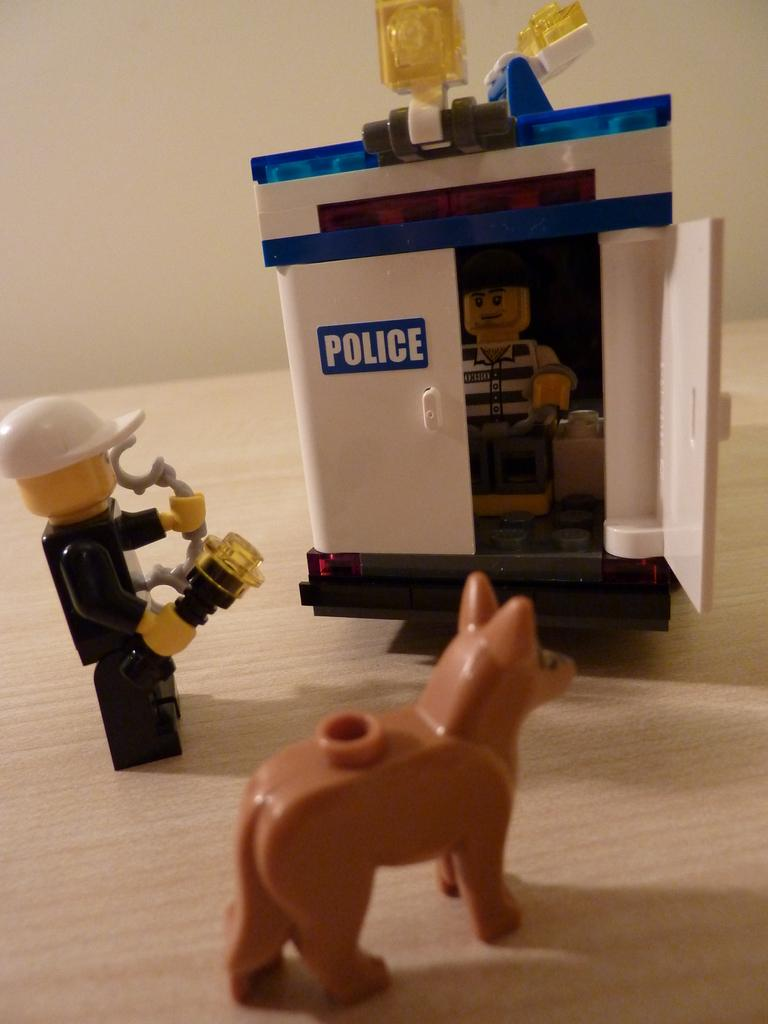What objects are placed on the wooden table in the image? There are toys placed on a wooden table in the image. What can be seen in the background of the image? There is a wall in the background of the image. What theory does the queen propose in the image? There is no queen or any discussion of a theory present in the image. 